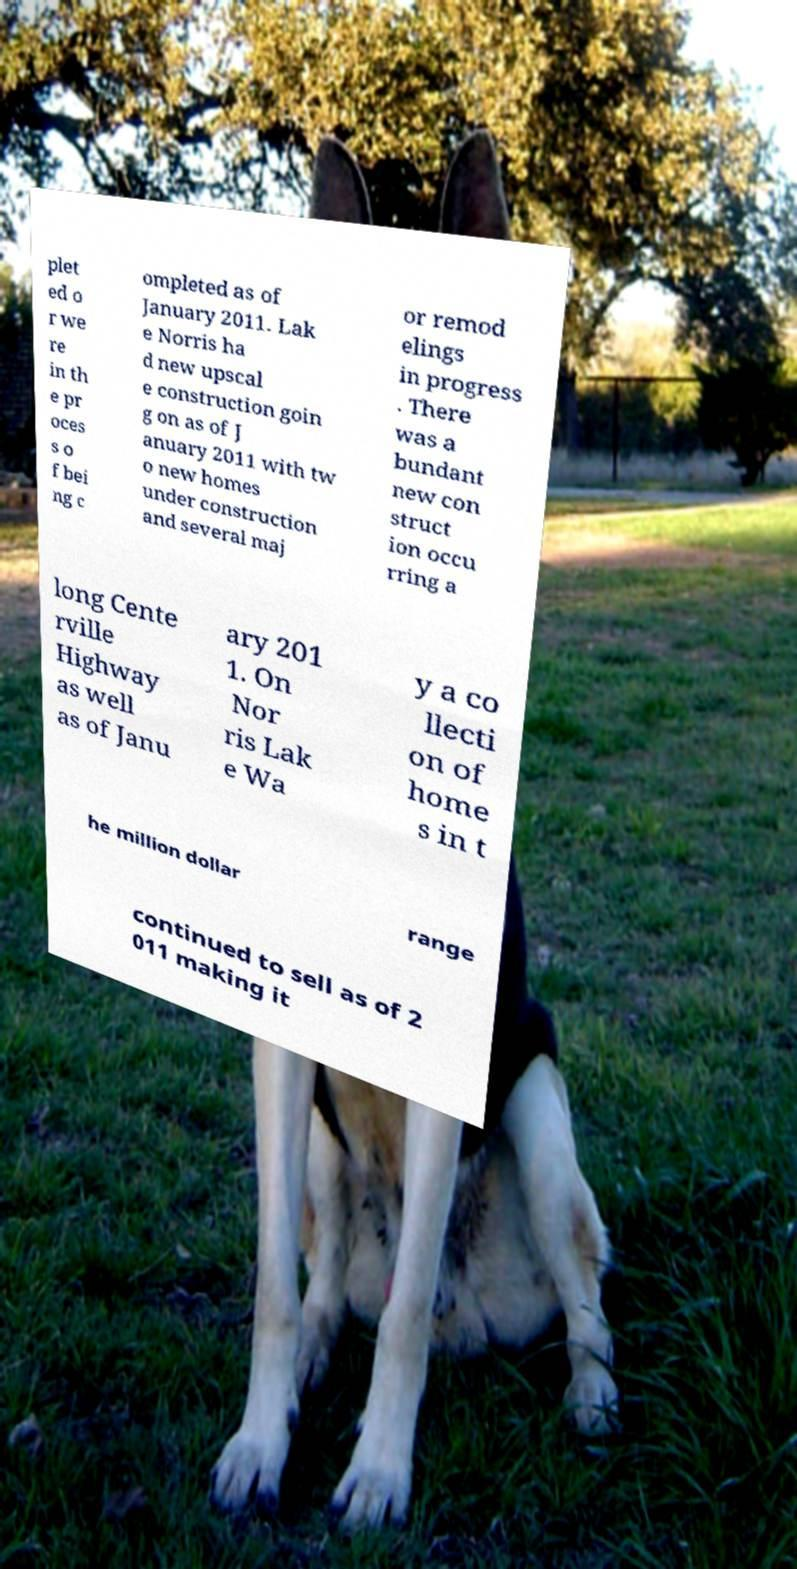For documentation purposes, I need the text within this image transcribed. Could you provide that? plet ed o r we re in th e pr oces s o f bei ng c ompleted as of January 2011. Lak e Norris ha d new upscal e construction goin g on as of J anuary 2011 with tw o new homes under construction and several maj or remod elings in progress . There was a bundant new con struct ion occu rring a long Cente rville Highway as well as of Janu ary 201 1. On Nor ris Lak e Wa y a co llecti on of home s in t he million dollar range continued to sell as of 2 011 making it 